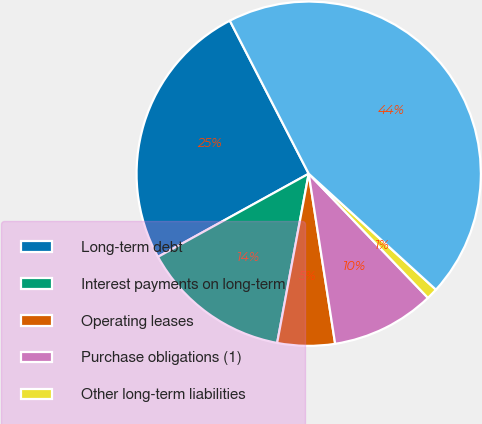Convert chart to OTSL. <chart><loc_0><loc_0><loc_500><loc_500><pie_chart><fcel>Long-term debt<fcel>Interest payments on long-term<fcel>Operating leases<fcel>Purchase obligations (1)<fcel>Other long-term liabilities<fcel>Total contractual obligations<nl><fcel>25.45%<fcel>14.04%<fcel>5.39%<fcel>9.72%<fcel>1.06%<fcel>44.34%<nl></chart> 